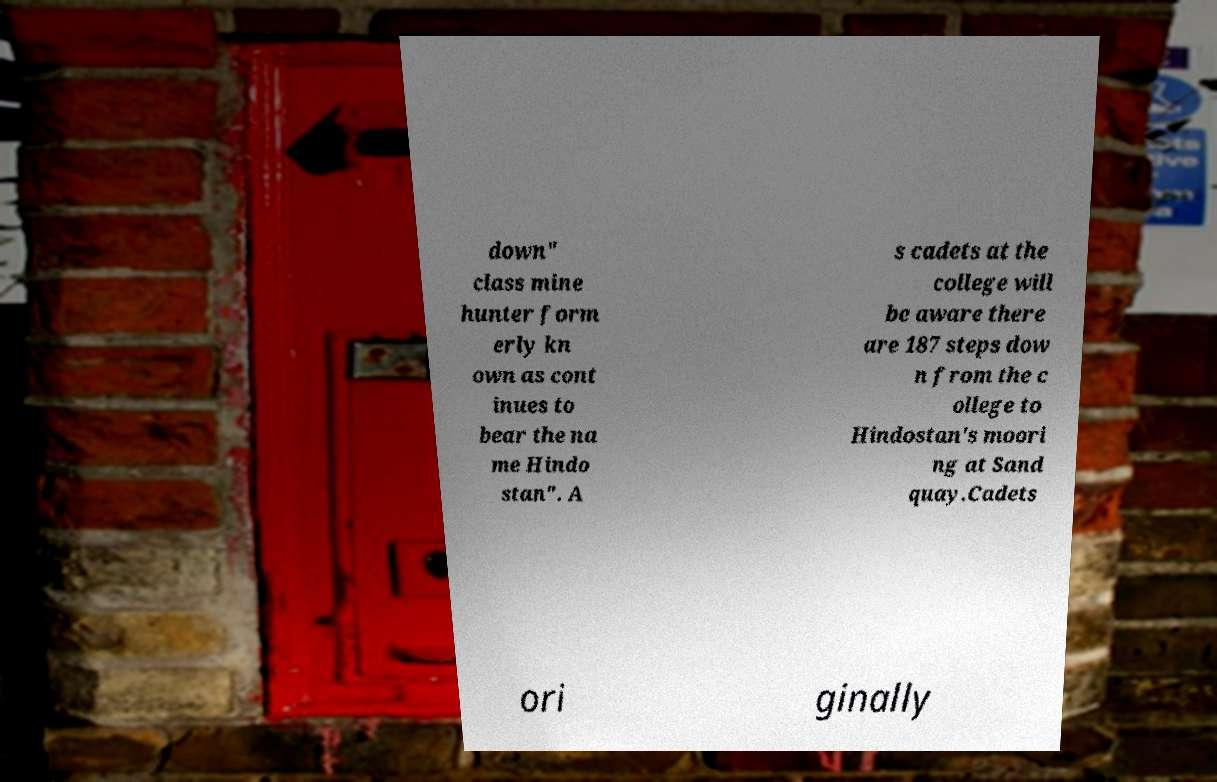Could you extract and type out the text from this image? down" class mine hunter form erly kn own as cont inues to bear the na me Hindo stan". A s cadets at the college will be aware there are 187 steps dow n from the c ollege to Hindostan's moori ng at Sand quay.Cadets ori ginally 